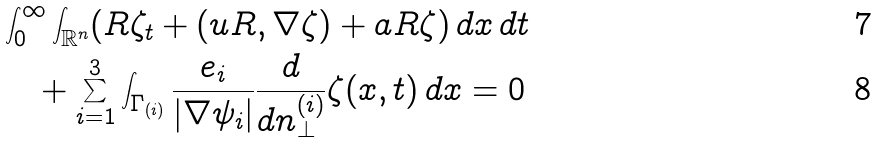Convert formula to latex. <formula><loc_0><loc_0><loc_500><loc_500>& \int ^ { \infty } _ { 0 } \int _ { \mathbb { R } ^ { n } } ( R \zeta _ { t } + ( u R , \nabla \zeta ) + a R \zeta ) \, d x \, d t \\ & \quad + \sum ^ { 3 } _ { i = 1 } \int _ { \Gamma _ { ( i ) } } \frac { e _ { i } } { | \nabla \psi _ { i } | } \frac { d } { d n ^ { ( i ) } _ { \perp } } \zeta ( x , t ) \, d x = 0</formula> 